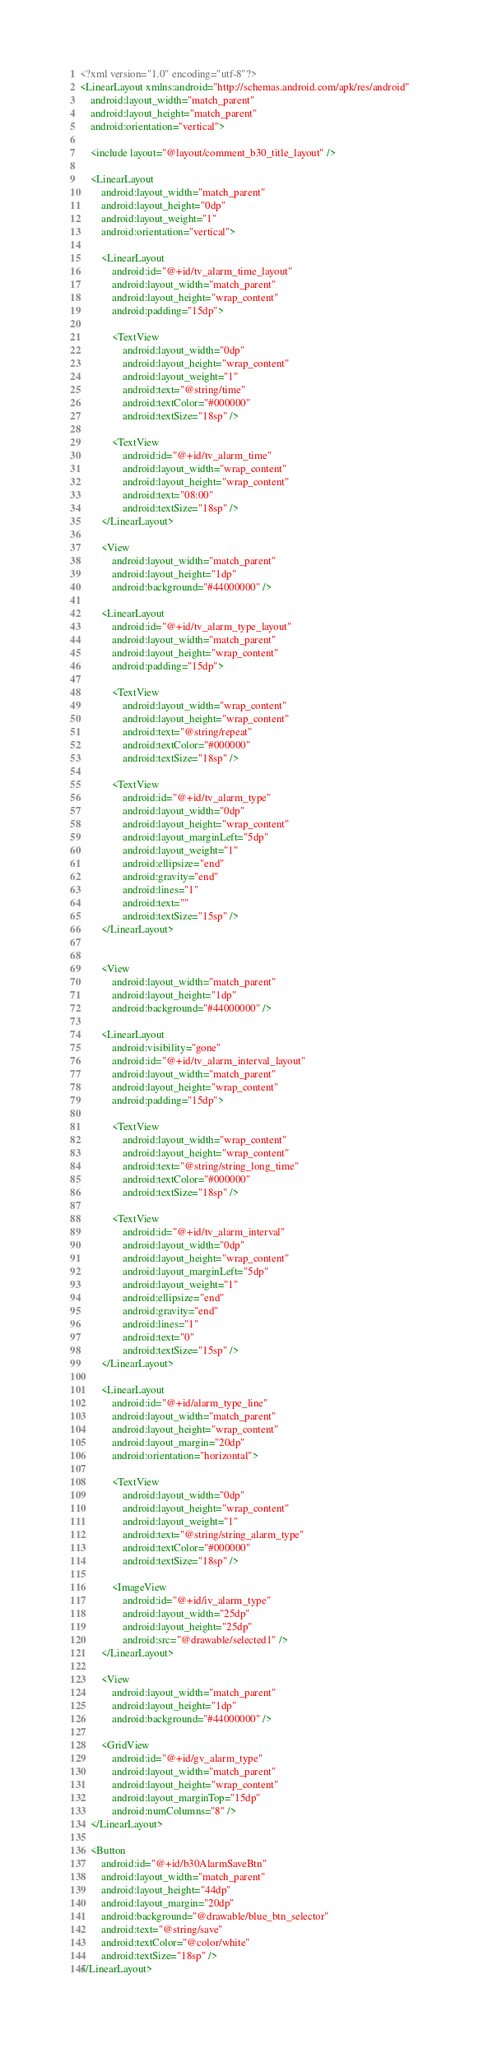<code> <loc_0><loc_0><loc_500><loc_500><_XML_><?xml version="1.0" encoding="utf-8"?>
<LinearLayout xmlns:android="http://schemas.android.com/apk/res/android"
    android:layout_width="match_parent"
    android:layout_height="match_parent"
    android:orientation="vertical">

    <include layout="@layout/comment_b30_title_layout" />

    <LinearLayout
        android:layout_width="match_parent"
        android:layout_height="0dp"
        android:layout_weight="1"
        android:orientation="vertical">

        <LinearLayout
            android:id="@+id/tv_alarm_time_layout"
            android:layout_width="match_parent"
            android:layout_height="wrap_content"
            android:padding="15dp">

            <TextView
                android:layout_width="0dp"
                android:layout_height="wrap_content"
                android:layout_weight="1"
                android:text="@string/time"
                android:textColor="#000000"
                android:textSize="18sp" />

            <TextView
                android:id="@+id/tv_alarm_time"
                android:layout_width="wrap_content"
                android:layout_height="wrap_content"
                android:text="08:00"
                android:textSize="18sp" />
        </LinearLayout>

        <View
            android:layout_width="match_parent"
            android:layout_height="1dp"
            android:background="#44000000" />

        <LinearLayout
            android:id="@+id/tv_alarm_type_layout"
            android:layout_width="match_parent"
            android:layout_height="wrap_content"
            android:padding="15dp">

            <TextView
                android:layout_width="wrap_content"
                android:layout_height="wrap_content"
                android:text="@string/repeat"
                android:textColor="#000000"
                android:textSize="18sp" />

            <TextView
                android:id="@+id/tv_alarm_type"
                android:layout_width="0dp"
                android:layout_height="wrap_content"
                android:layout_marginLeft="5dp"
                android:layout_weight="1"
                android:ellipsize="end"
                android:gravity="end"
                android:lines="1"
                android:text=""
                android:textSize="15sp" />
        </LinearLayout>


        <View
            android:layout_width="match_parent"
            android:layout_height="1dp"
            android:background="#44000000" />

        <LinearLayout
            android:visibility="gone"
            android:id="@+id/tv_alarm_interval_layout"
            android:layout_width="match_parent"
            android:layout_height="wrap_content"
            android:padding="15dp">

            <TextView
                android:layout_width="wrap_content"
                android:layout_height="wrap_content"
                android:text="@string/string_long_time"
                android:textColor="#000000"
                android:textSize="18sp" />

            <TextView
                android:id="@+id/tv_alarm_interval"
                android:layout_width="0dp"
                android:layout_height="wrap_content"
                android:layout_marginLeft="5dp"
                android:layout_weight="1"
                android:ellipsize="end"
                android:gravity="end"
                android:lines="1"
                android:text="0"
                android:textSize="15sp" />
        </LinearLayout>

        <LinearLayout
            android:id="@+id/alarm_type_line"
            android:layout_width="match_parent"
            android:layout_height="wrap_content"
            android:layout_margin="20dp"
            android:orientation="horizontal">

            <TextView
                android:layout_width="0dp"
                android:layout_height="wrap_content"
                android:layout_weight="1"
                android:text="@string/string_alarm_type"
                android:textColor="#000000"
                android:textSize="18sp" />

            <ImageView
                android:id="@+id/iv_alarm_type"
                android:layout_width="25dp"
                android:layout_height="25dp"
                android:src="@drawable/selected1" />
        </LinearLayout>

        <View
            android:layout_width="match_parent"
            android:layout_height="1dp"
            android:background="#44000000" />

        <GridView
            android:id="@+id/gv_alarm_type"
            android:layout_width="match_parent"
            android:layout_height="wrap_content"
            android:layout_marginTop="15dp"
            android:numColumns="8" />
    </LinearLayout>

    <Button
        android:id="@+id/b30AlarmSaveBtn"
        android:layout_width="match_parent"
        android:layout_height="44dp"
        android:layout_margin="20dp"
        android:background="@drawable/blue_btn_selector"
        android:text="@string/save"
        android:textColor="@color/white"
        android:textSize="18sp" />
</LinearLayout></code> 